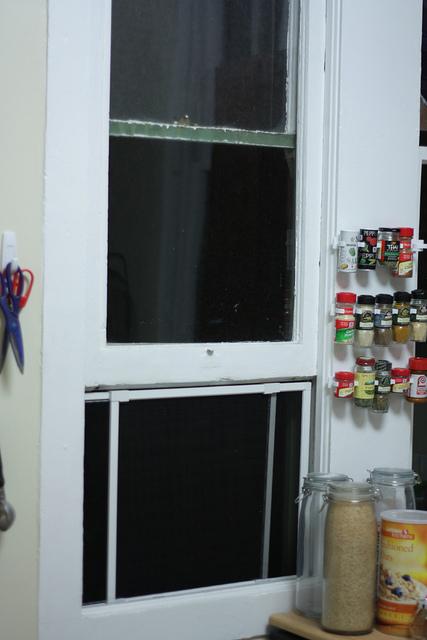What kind of room is this?
Keep it brief. Kitchen. How many window panes are there?
Short answer required. 2. Are the spices held by clamps?
Give a very brief answer. Yes. Is a window present in the picture shown?
Be succinct. Yes. Is the window open?
Keep it brief. No. What color liquid is in the glass?
Give a very brief answer. Brown. Is there a spice rack under the frying pans?
Be succinct. No. 